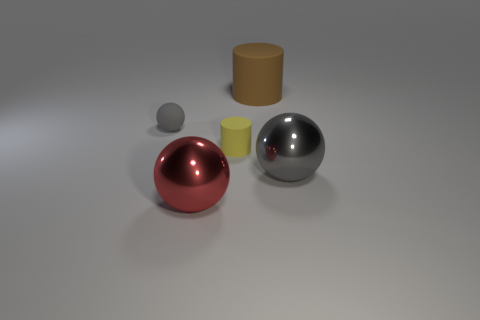Subtract all gray matte spheres. How many spheres are left? 2 Add 3 yellow objects. How many objects exist? 8 Subtract all cylinders. How many objects are left? 3 Subtract all gray balls. Subtract all green cylinders. How many balls are left? 1 Subtract all green cubes. How many gray balls are left? 2 Subtract all red metallic things. Subtract all blue metallic cylinders. How many objects are left? 4 Add 2 yellow things. How many yellow things are left? 3 Add 1 tiny purple things. How many tiny purple things exist? 1 Subtract all red balls. How many balls are left? 2 Subtract 0 blue cylinders. How many objects are left? 5 